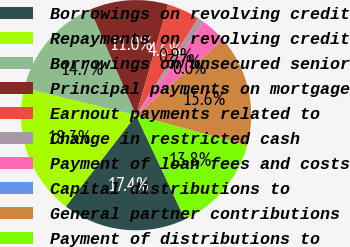Convert chart. <chart><loc_0><loc_0><loc_500><loc_500><pie_chart><fcel>Borrowings on revolving credit<fcel>Repayments on revolving credit<fcel>Borrowings on unsecured senior<fcel>Principal payments on mortgage<fcel>Earnout payments related to<fcel>Change in restricted cash<fcel>Payment of loan fees and costs<fcel>Capital distributions to<fcel>General partner contributions<fcel>Payment of distributions to<nl><fcel>17.43%<fcel>18.35%<fcel>14.68%<fcel>11.01%<fcel>4.59%<fcel>0.92%<fcel>3.67%<fcel>0.0%<fcel>15.6%<fcel>13.76%<nl></chart> 